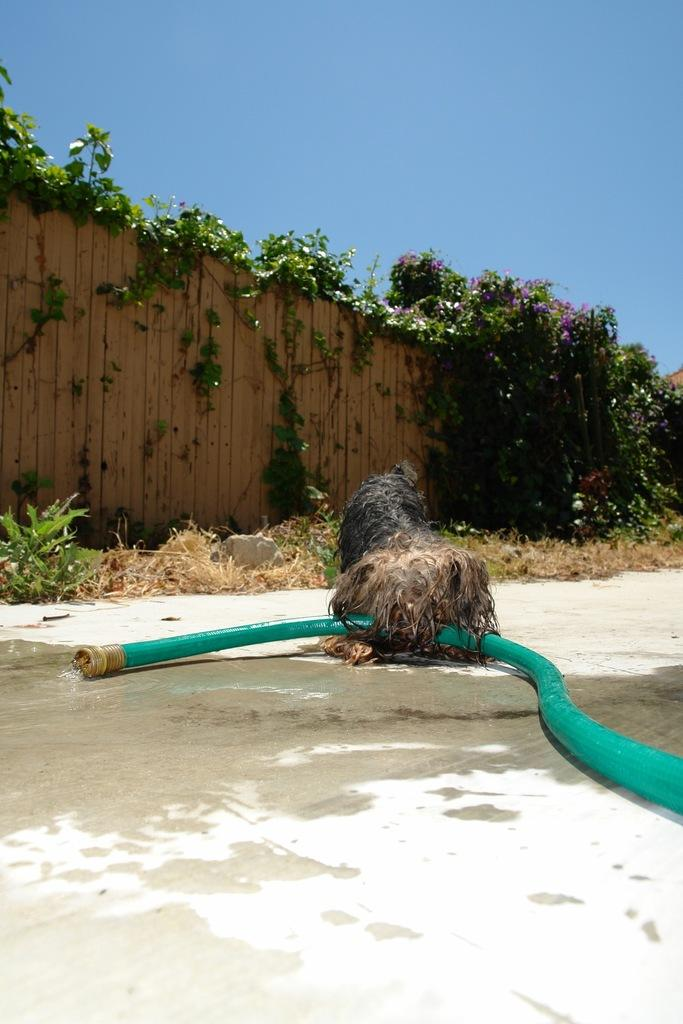What object can be seen in the image that is typically used for transporting fluids? There is a pipe in the image that is typically used for transporting fluids. What type of animal is present in the image? There is a dog in the image. What type of surface is in front of the dog? There is grass on the surface in front of the dog. What is in front of the grass? There is a wooden fence in front of the grass. What is on top of the wooden fence? There are leaves on top of the wooden fence. What type of underwear is the dog wearing in the image? There is no underwear present in the image, and dogs do not wear underwear. What is the copper content of the pipe in the image? The facts provided do not mention the material of the pipe, so it is impossible to determine the copper content. 